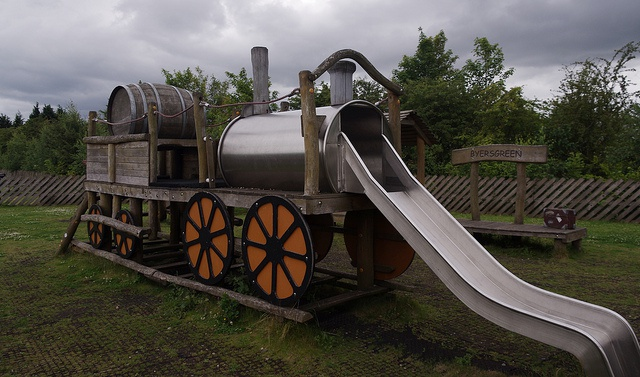Describe the objects in this image and their specific colors. I can see train in lightgray, black, gray, darkgray, and maroon tones and bench in lightgray, black, gray, and darkgreen tones in this image. 